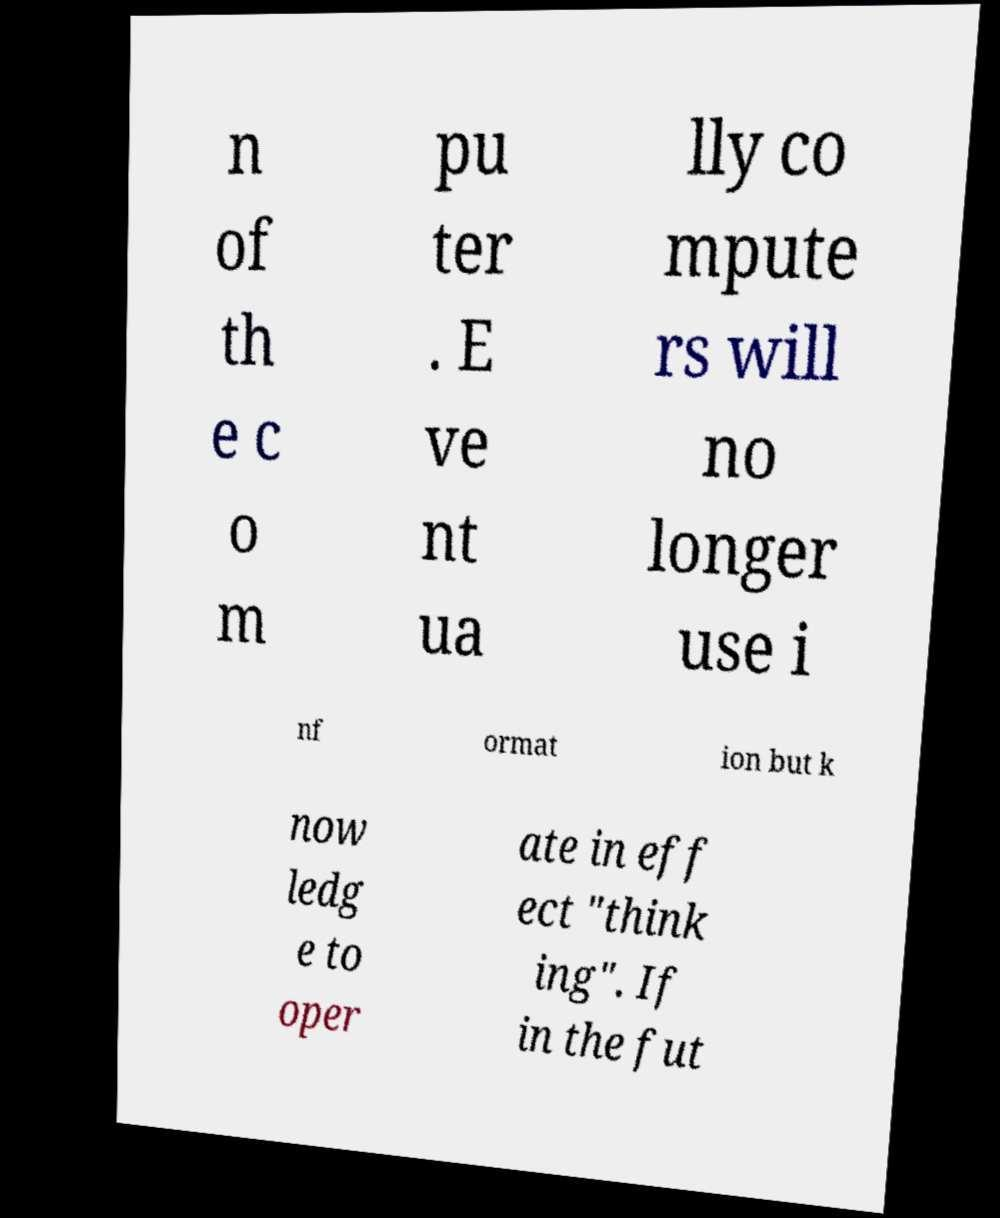I need the written content from this picture converted into text. Can you do that? n of th e c o m pu ter . E ve nt ua lly co mpute rs will no longer use i nf ormat ion but k now ledg e to oper ate in eff ect "think ing". If in the fut 